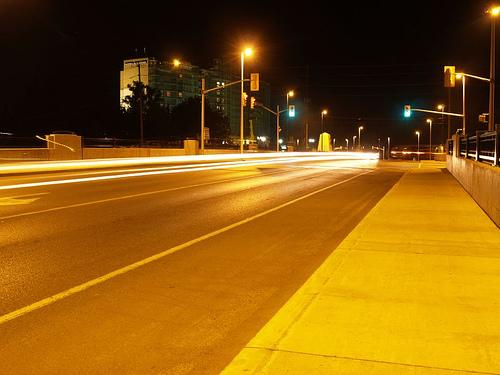What should traffic do?
Answer briefly. Go. Do city lights create light pollution in a big city?
Concise answer only. Yes. Are the street lamps on?
Answer briefly. Yes. 